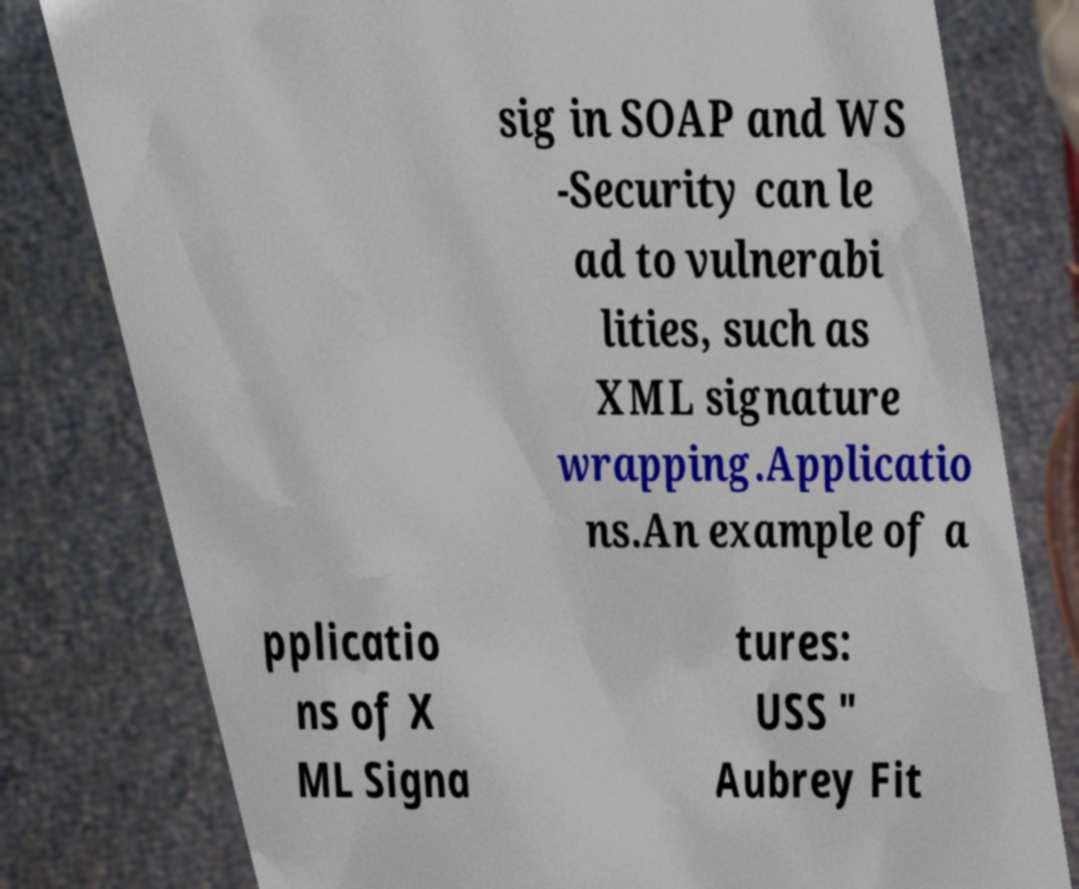Can you read and provide the text displayed in the image?This photo seems to have some interesting text. Can you extract and type it out for me? sig in SOAP and WS -Security can le ad to vulnerabi lities, such as XML signature wrapping.Applicatio ns.An example of a pplicatio ns of X ML Signa tures: USS " Aubrey Fit 